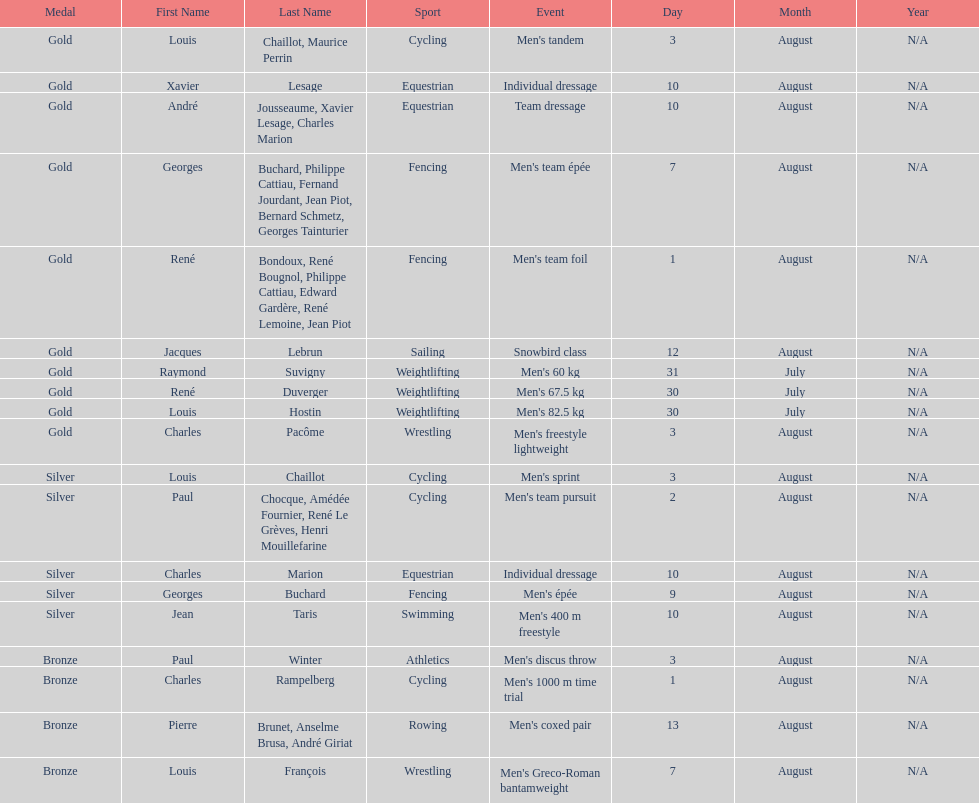Louis chaillot won a gold medal for cycling and a silver medal for what sport? Cycling. 